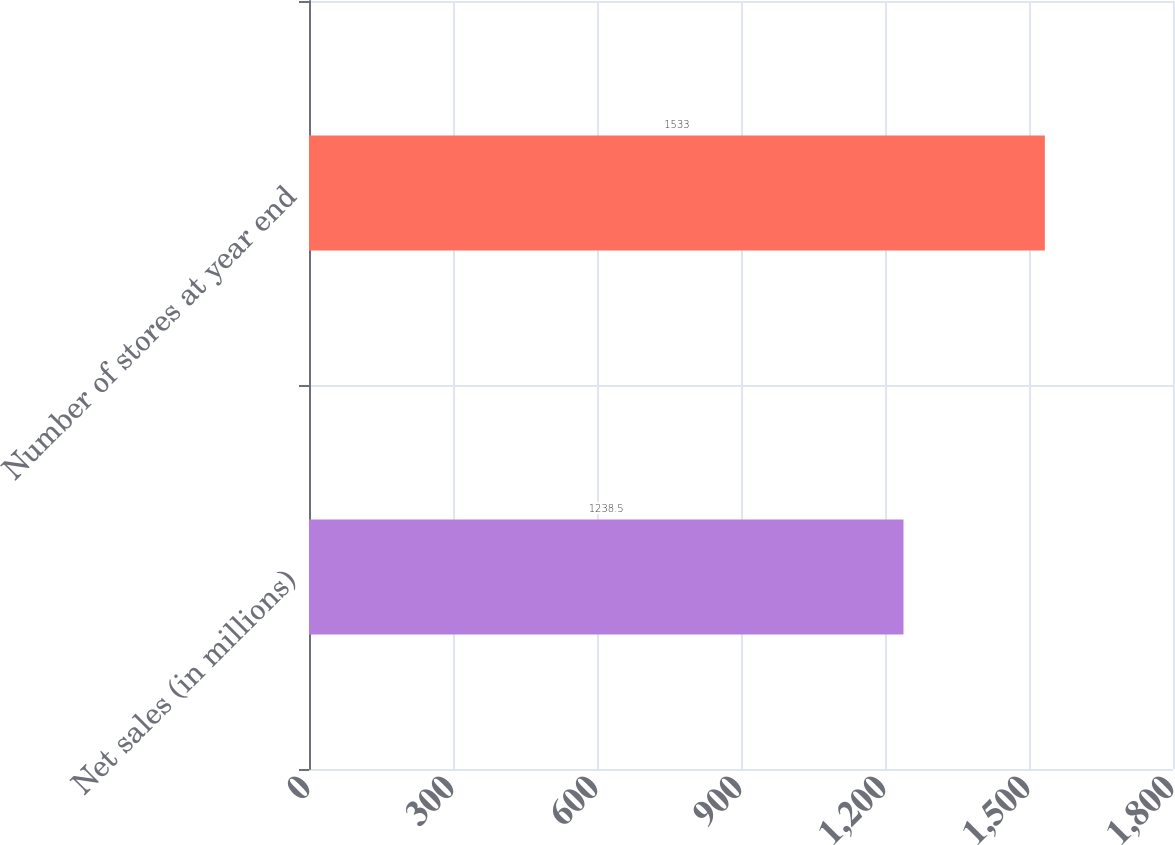Convert chart to OTSL. <chart><loc_0><loc_0><loc_500><loc_500><bar_chart><fcel>Net sales (in millions)<fcel>Number of stores at year end<nl><fcel>1238.5<fcel>1533<nl></chart> 